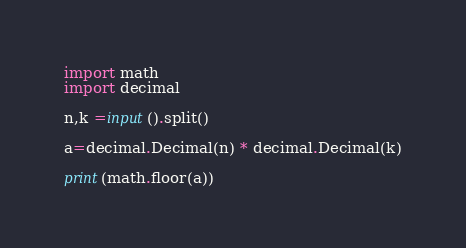<code> <loc_0><loc_0><loc_500><loc_500><_Python_>import math
import decimal

n,k =input().split()

a=decimal.Decimal(n) * decimal.Decimal(k)

print(math.floor(a))</code> 